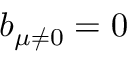<formula> <loc_0><loc_0><loc_500><loc_500>b _ { \mu \ne 0 } = 0</formula> 